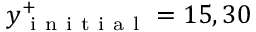<formula> <loc_0><loc_0><loc_500><loc_500>y _ { i n i t i a l } ^ { + } = 1 5 , 3 0</formula> 